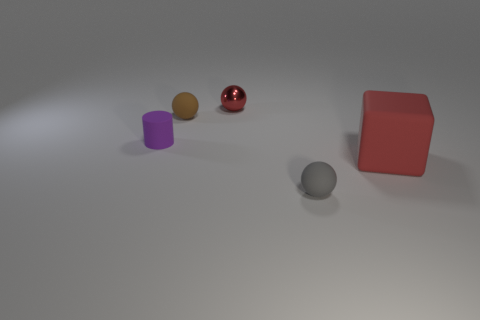Is there any other thing that has the same shape as the purple object?
Your response must be concise. No. Are there an equal number of tiny matte objects that are left of the small red ball and big matte cubes?
Your answer should be very brief. No. What number of objects are in front of the small metal thing and right of the tiny brown rubber sphere?
Your answer should be compact. 2. There is a gray matte thing that is the same shape as the red metallic thing; what is its size?
Keep it short and to the point. Small. What number of objects have the same material as the purple cylinder?
Your answer should be compact. 3. Are there fewer small cylinders in front of the big matte thing than gray rubber spheres?
Keep it short and to the point. Yes. What number of balls are there?
Keep it short and to the point. 3. How many other big matte blocks are the same color as the cube?
Keep it short and to the point. 0. Is the shape of the large rubber thing the same as the metallic thing?
Offer a terse response. No. How big is the matte ball that is in front of the red object in front of the tiny rubber cylinder?
Ensure brevity in your answer.  Small. 